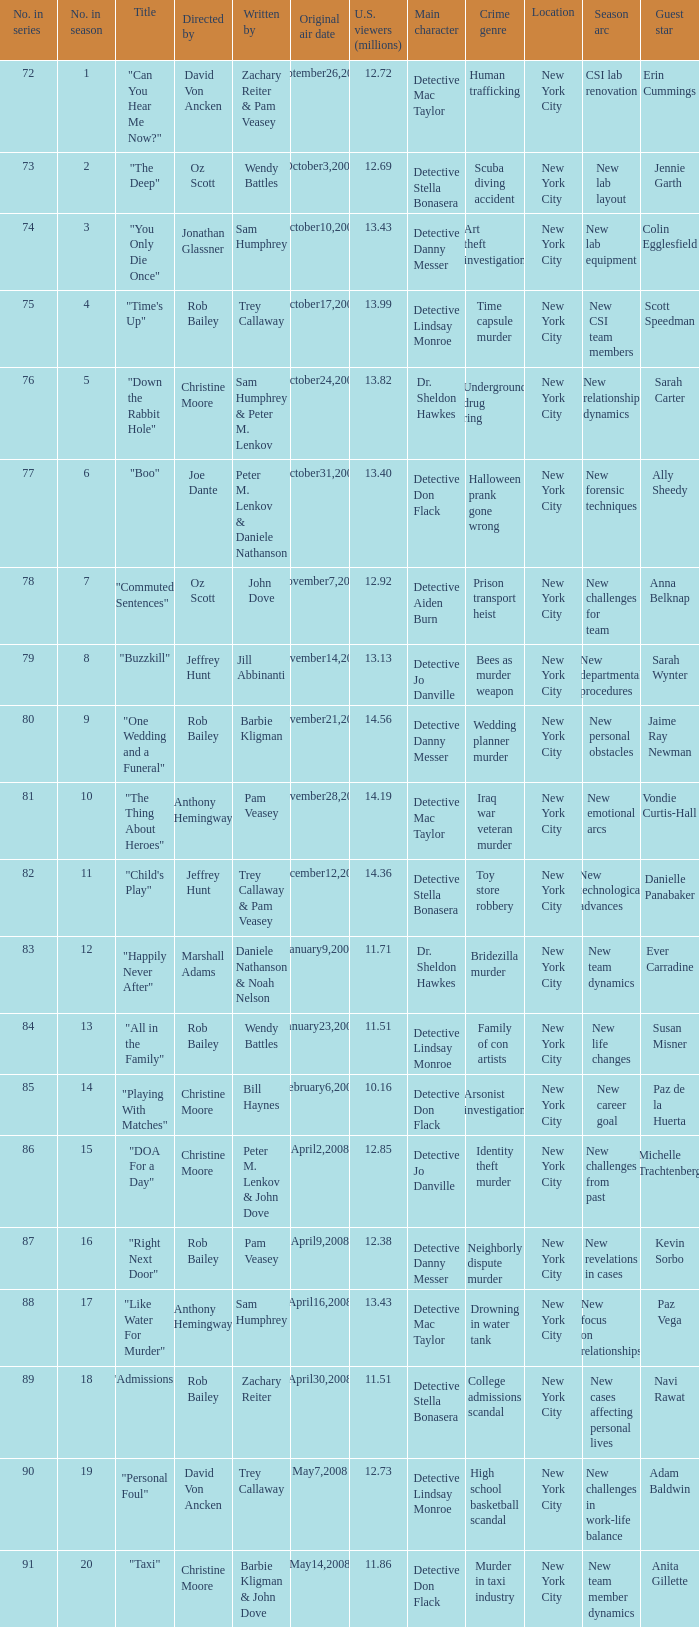How many episodes were watched by 12.72 million U.S. viewers? 1.0. Give me the full table as a dictionary. {'header': ['No. in series', 'No. in season', 'Title', 'Directed by', 'Written by', 'Original air date', 'U.S. viewers (millions)', 'Main character', 'Crime genre', 'Location', 'Season arc', 'Guest star'], 'rows': [['72', '1', '"Can You Hear Me Now?"', 'David Von Ancken', 'Zachary Reiter & Pam Veasey', 'September26,2007', '12.72', 'Detective Mac Taylor', 'Human trafficking', 'New York City', 'CSI lab renovation', 'Erin Cummings'], ['73', '2', '"The Deep"', 'Oz Scott', 'Wendy Battles', 'October3,2007', '12.69', 'Detective Stella Bonasera', 'Scuba diving accident', 'New York City', 'New lab layout', 'Jennie Garth'], ['74', '3', '"You Only Die Once"', 'Jonathan Glassner', 'Sam Humphrey', 'October10,2007', '13.43', 'Detective Danny Messer', 'Art theft investigation', 'New York City', 'New lab equipment', 'Colin Egglesfield'], ['75', '4', '"Time\'s Up"', 'Rob Bailey', 'Trey Callaway', 'October17,2007', '13.99', 'Detective Lindsay Monroe', 'Time capsule murder', 'New York City', 'New CSI team members', 'Scott Speedman'], ['76', '5', '"Down the Rabbit Hole"', 'Christine Moore', 'Sam Humphrey & Peter M. Lenkov', 'October24,2007', '13.82', 'Dr. Sheldon Hawkes', 'Underground drug ring', 'New York City', 'New relationship dynamics', 'Sarah Carter'], ['77', '6', '"Boo"', 'Joe Dante', 'Peter M. Lenkov & Daniele Nathanson', 'October31,2007', '13.40', 'Detective Don Flack', 'Halloween prank gone wrong', 'New York City', 'New forensic techniques', 'Ally Sheedy'], ['78', '7', '"Commuted Sentences"', 'Oz Scott', 'John Dove', 'November7,2007', '12.92', 'Detective Aiden Burn', 'Prison transport heist', 'New York City', 'New challenges for team', 'Anna Belknap'], ['79', '8', '"Buzzkill"', 'Jeffrey Hunt', 'Jill Abbinanti', 'November14,2007', '13.13', 'Detective Jo Danville', 'Bees as murder weapon', 'New York City', 'New departmental procedures', 'Sarah Wynter'], ['80', '9', '"One Wedding and a Funeral"', 'Rob Bailey', 'Barbie Kligman', 'November21,2007', '14.56', 'Detective Danny Messer', 'Wedding planner murder', 'New York City', 'New personal obstacles', 'Jaime Ray Newman'], ['81', '10', '"The Thing About Heroes"', 'Anthony Hemingway', 'Pam Veasey', 'November28,2007', '14.19', 'Detective Mac Taylor', 'Iraq war veteran murder', 'New York City', 'New emotional arcs', 'Vondie Curtis-Hall'], ['82', '11', '"Child\'s Play"', 'Jeffrey Hunt', 'Trey Callaway & Pam Veasey', 'December12,2007', '14.36', 'Detective Stella Bonasera', 'Toy store robbery', 'New York City', 'New technological advances', 'Danielle Panabaker'], ['83', '12', '"Happily Never After"', 'Marshall Adams', 'Daniele Nathanson & Noah Nelson', 'January9,2008', '11.71', 'Dr. Sheldon Hawkes', 'Bridezilla murder', 'New York City', 'New team dynamics', 'Ever Carradine'], ['84', '13', '"All in the Family"', 'Rob Bailey', 'Wendy Battles', 'January23,2008', '11.51', 'Detective Lindsay Monroe', 'Family of con artists', 'New York City', 'New life changes', 'Susan Misner'], ['85', '14', '"Playing With Matches"', 'Christine Moore', 'Bill Haynes', 'February6,2008', '10.16', 'Detective Don Flack', 'Arsonist investigation', 'New York City', 'New career goal', 'Paz de la Huerta'], ['86', '15', '"DOA For a Day"', 'Christine Moore', 'Peter M. Lenkov & John Dove', 'April2,2008', '12.85', 'Detective Jo Danville', 'Identity theft murder', 'New York City', 'New challenges from past', 'Michelle Trachtenberg'], ['87', '16', '"Right Next Door"', 'Rob Bailey', 'Pam Veasey', 'April9,2008', '12.38', 'Detective Danny Messer', 'Neighborly dispute murder', 'New York City', 'New revelations in cases', 'Kevin Sorbo'], ['88', '17', '"Like Water For Murder"', 'Anthony Hemingway', 'Sam Humphrey', 'April16,2008', '13.43', 'Detective Mac Taylor', 'Drowning in water tank', 'New York City', 'New focus on relationships', 'Paz Vega'], ['89', '18', '"Admissions"', 'Rob Bailey', 'Zachary Reiter', 'April30,2008', '11.51', 'Detective Stella Bonasera', 'College admissions scandal', 'New York City', 'New cases affecting personal lives', 'Navi Rawat'], ['90', '19', '"Personal Foul"', 'David Von Ancken', 'Trey Callaway', 'May7,2008', '12.73', 'Detective Lindsay Monroe', 'High school basketball scandal', 'New York City', 'New challenges in work-life balance', 'Adam Baldwin'], ['91', '20', '"Taxi"', 'Christine Moore', 'Barbie Kligman & John Dove', 'May14,2008', '11.86', 'Detective Don Flack', 'Murder in taxi industry', 'New York City', 'New team member dynamics', 'Anita Gillette']]} 